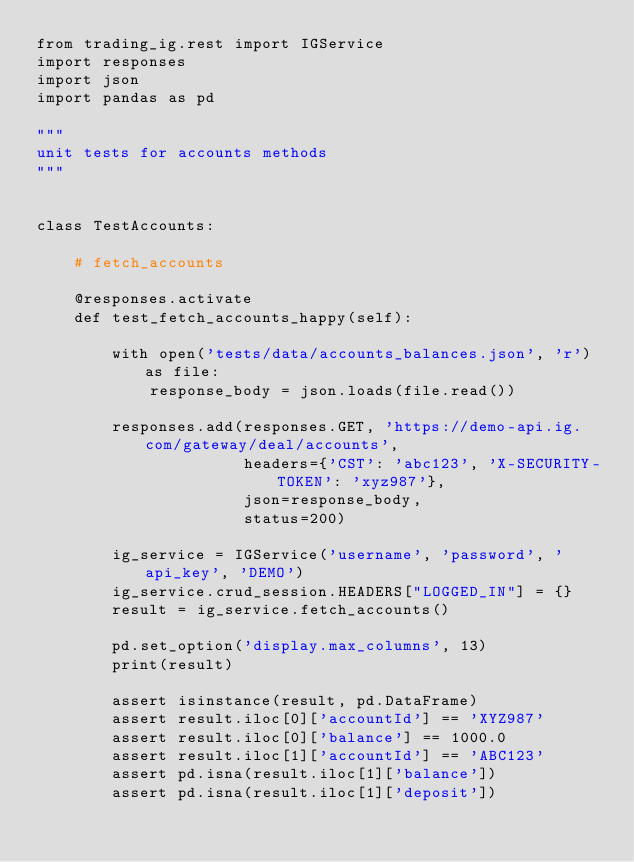<code> <loc_0><loc_0><loc_500><loc_500><_Python_>from trading_ig.rest import IGService
import responses
import json
import pandas as pd

"""
unit tests for accounts methods
"""


class TestAccounts:

    # fetch_accounts

    @responses.activate
    def test_fetch_accounts_happy(self):

        with open('tests/data/accounts_balances.json', 'r') as file:
            response_body = json.loads(file.read())

        responses.add(responses.GET, 'https://demo-api.ig.com/gateway/deal/accounts',
                      headers={'CST': 'abc123', 'X-SECURITY-TOKEN': 'xyz987'},
                      json=response_body,
                      status=200)

        ig_service = IGService('username', 'password', 'api_key', 'DEMO')
        ig_service.crud_session.HEADERS["LOGGED_IN"] = {}
        result = ig_service.fetch_accounts()

        pd.set_option('display.max_columns', 13)
        print(result)

        assert isinstance(result, pd.DataFrame)
        assert result.iloc[0]['accountId'] == 'XYZ987'
        assert result.iloc[0]['balance'] == 1000.0
        assert result.iloc[1]['accountId'] == 'ABC123'
        assert pd.isna(result.iloc[1]['balance'])
        assert pd.isna(result.iloc[1]['deposit'])
</code> 